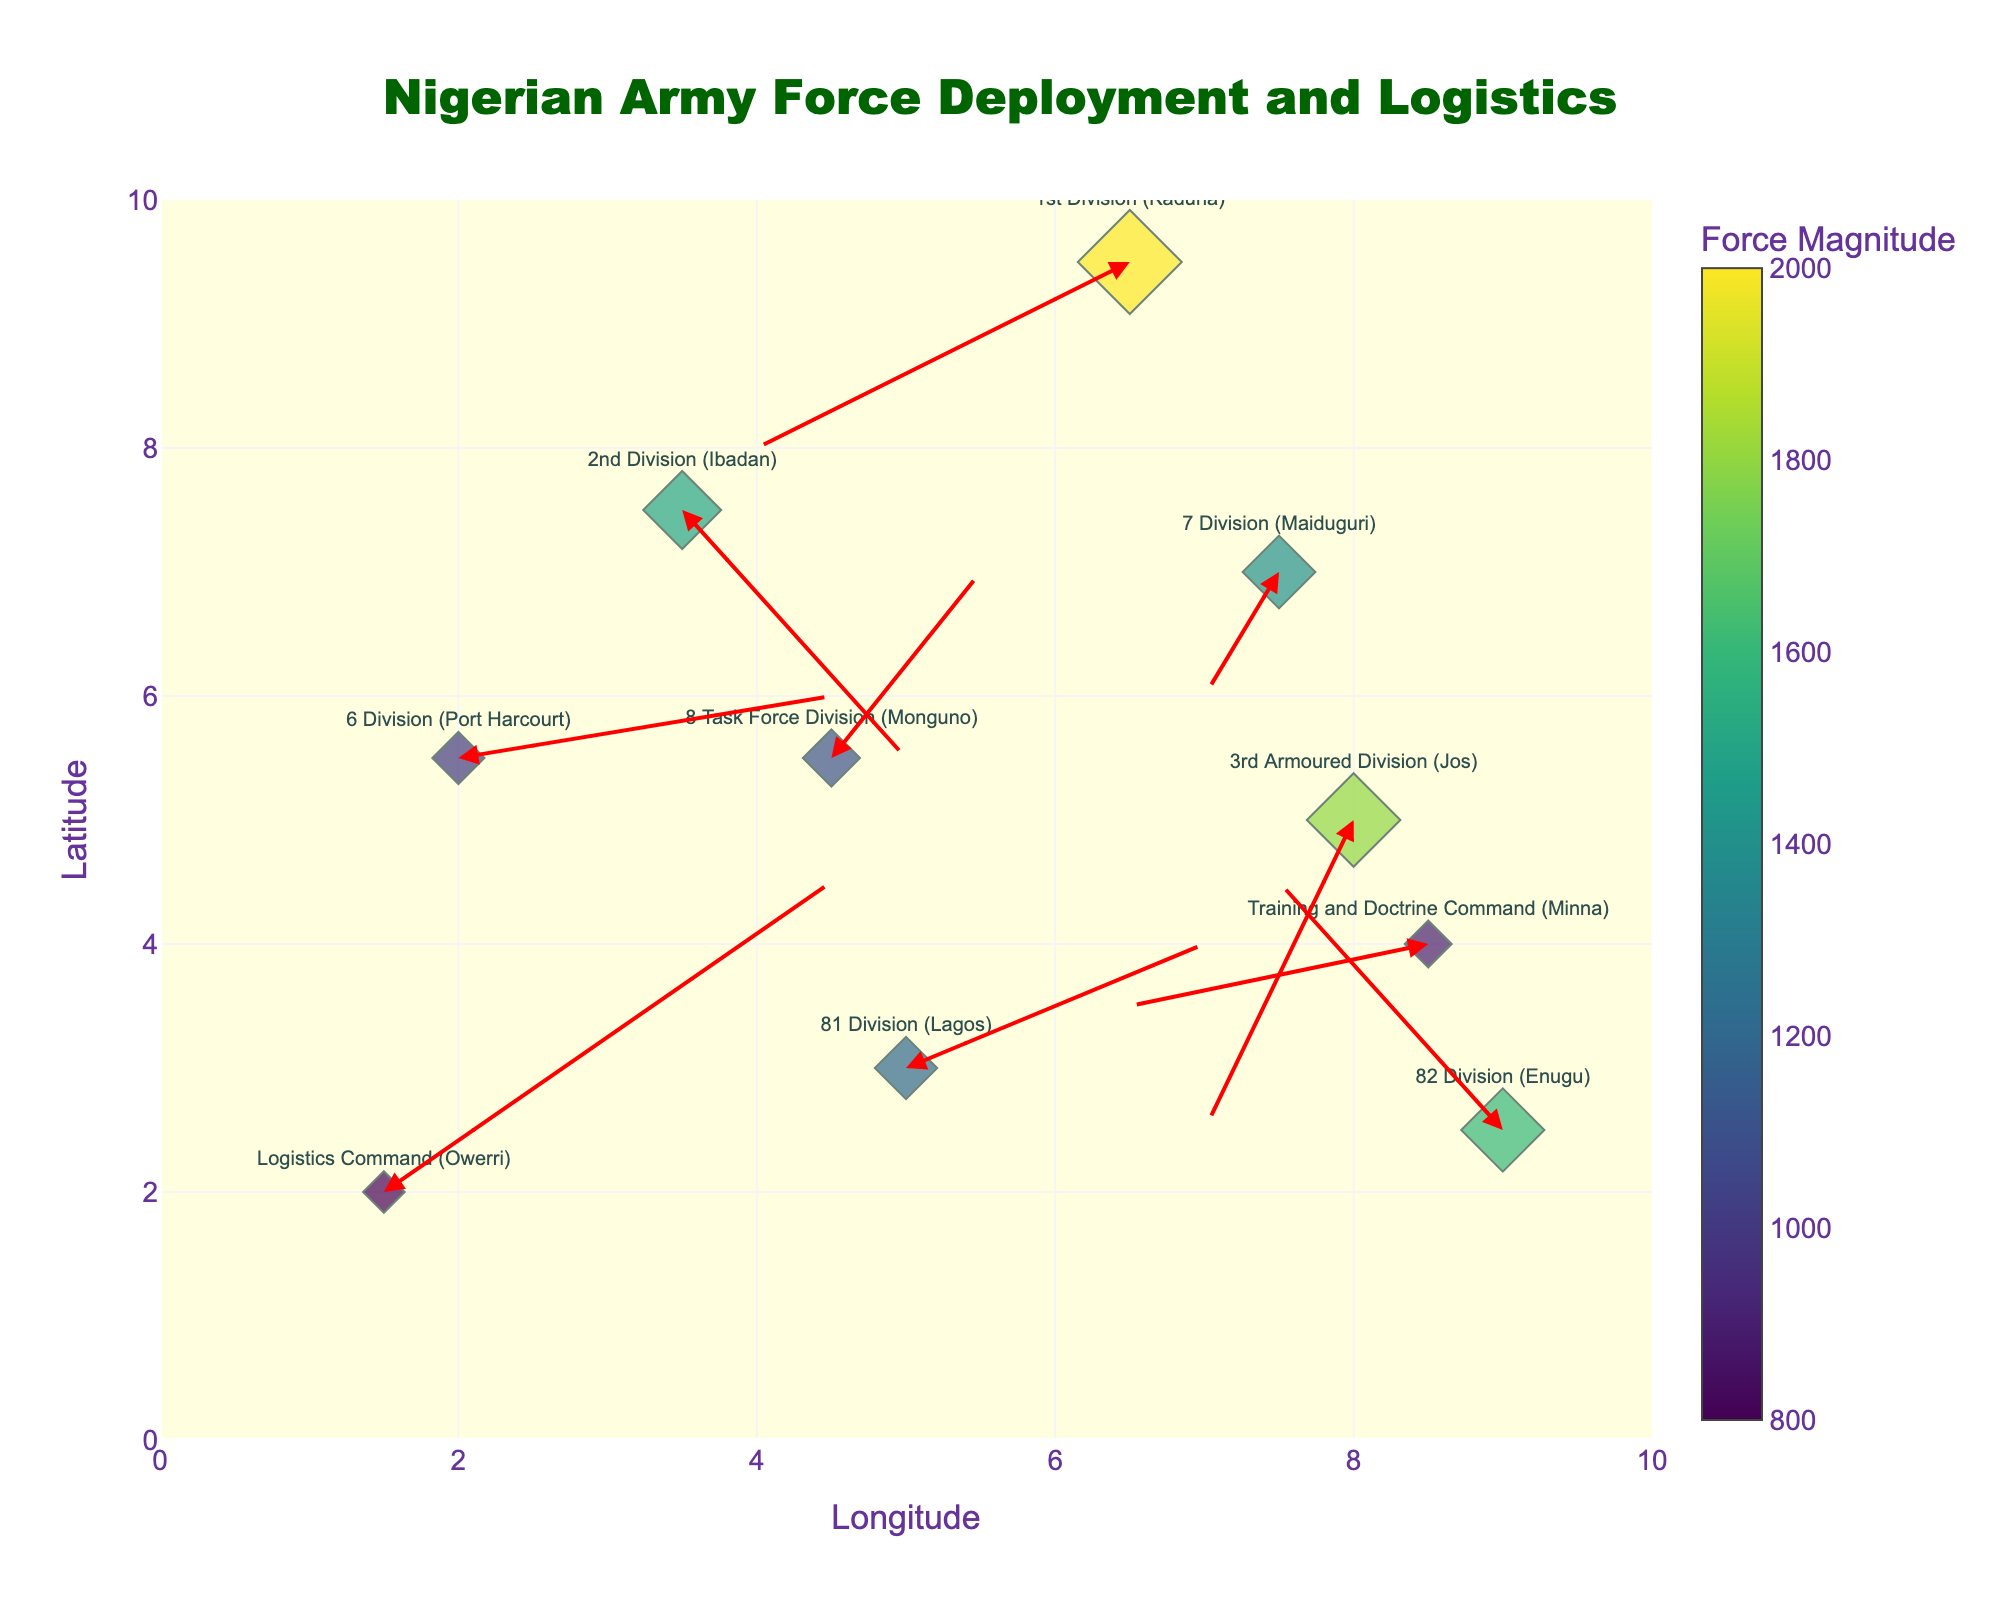What's the title of the figure? The title is typically located at the top of the figure, often in a larger, distinct font. For this plot, the title appears centered at the top in green text.
Answer: Nigerian Army Force Deployment and Logistics How many divisions are represented in the quiver plot? To determine the number of divisions, count the distinct markers or labels presented in the figure. Each division has a unique position paired with an arrow.
Answer: 10 Which division has the largest force magnitude? The force magnitude is indicated by the size and color of the diamonds. Looking for the diamond with the largest size and most intense color on the figure can identify this.
Answer: 1st Division (Kaduna) What is the approximate direction and distance of deployment for the 3rd Armoured Division (Jos)? Locate the label for "3rd Armoured Division (Jos)" on the plot. The arrow starting from this label's position indicates the deployment direction, with its length being proportional to the magnitude.
Answer: Southwest, moderate distance Which division deployed in the direction most toward the north? Observing the arrows, the division whose arrow points most upward (positive y-direction) on the plot indicates a northern deployment.
Answer: 82 Division (Enugu) Compare the force magnitudes of the 6 Division (Port Harcourt) and the Logistics Command (Owerri). Which one is larger? Locate the diamonds for the two divisions and compare their sizes and colors. The larger and more intensely colored diamond indicates a larger force magnitude.
Answer: 6 Division (Port Harcourt) Which division has the most complex logistical supply route based on the figure, considering the distance and direction? Identify the division whose arrow is the longest and possibly has multiple direction changes or seems most intricate.
Answer: Logistics Command (Owerri) What is the relative position of the 7 Division (Maiduguri) compared to the Training and Doctrine Command (Minna)? Identify both divisions on the plot and compare their positions in terms of their x (longitude) and y (latitude) coordinates – determining which is more northern or eastern.
Answer: 7 Division (Maiduguri) is northeast of Training and Doctrine Command (Minna) Which two divisions have the closest deployment arrows in terms of direction? By examining the arrows' directions, find the two arrows that are nearly parallel or pointing in almost the same direction.
Answer: 2nd Division (Ibadan) and 3rd Armoured Division (Jos) 